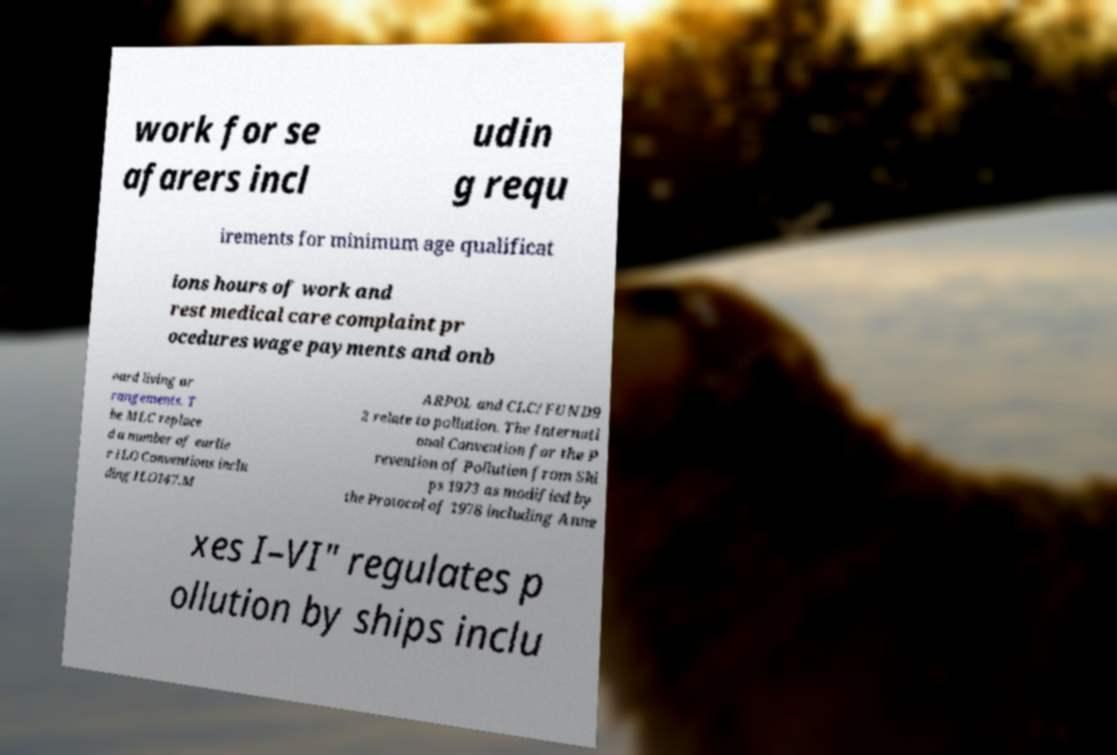Please identify and transcribe the text found in this image. work for se afarers incl udin g requ irements for minimum age qualificat ions hours of work and rest medical care complaint pr ocedures wage payments and onb oard living ar rangements. T he MLC replace d a number of earlie r ILO Conventions inclu ding ILO147.M ARPOL and CLC/FUND9 2 relate to pollution. The Internati onal Convention for the P revention of Pollution from Shi ps 1973 as modified by the Protocol of 1978 including Anne xes I–VI" regulates p ollution by ships inclu 